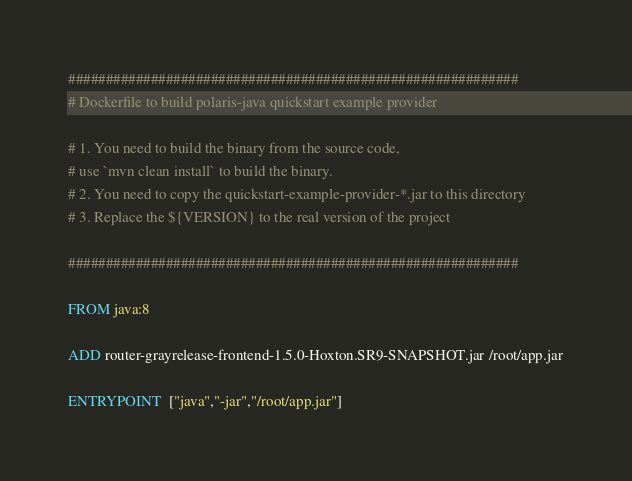Convert code to text. <code><loc_0><loc_0><loc_500><loc_500><_Dockerfile_>############################################################
# Dockerfile to build polaris-java quickstart example provider

# 1. You need to build the binary from the source code,
# use `mvn clean install` to build the binary.
# 2. You need to copy the quickstart-example-provider-*.jar to this directory
# 3. Replace the ${VERSION} to the real version of the project

############################################################

FROM java:8

ADD router-grayrelease-frontend-1.5.0-Hoxton.SR9-SNAPSHOT.jar /root/app.jar

ENTRYPOINT  ["java","-jar","/root/app.jar"]</code> 